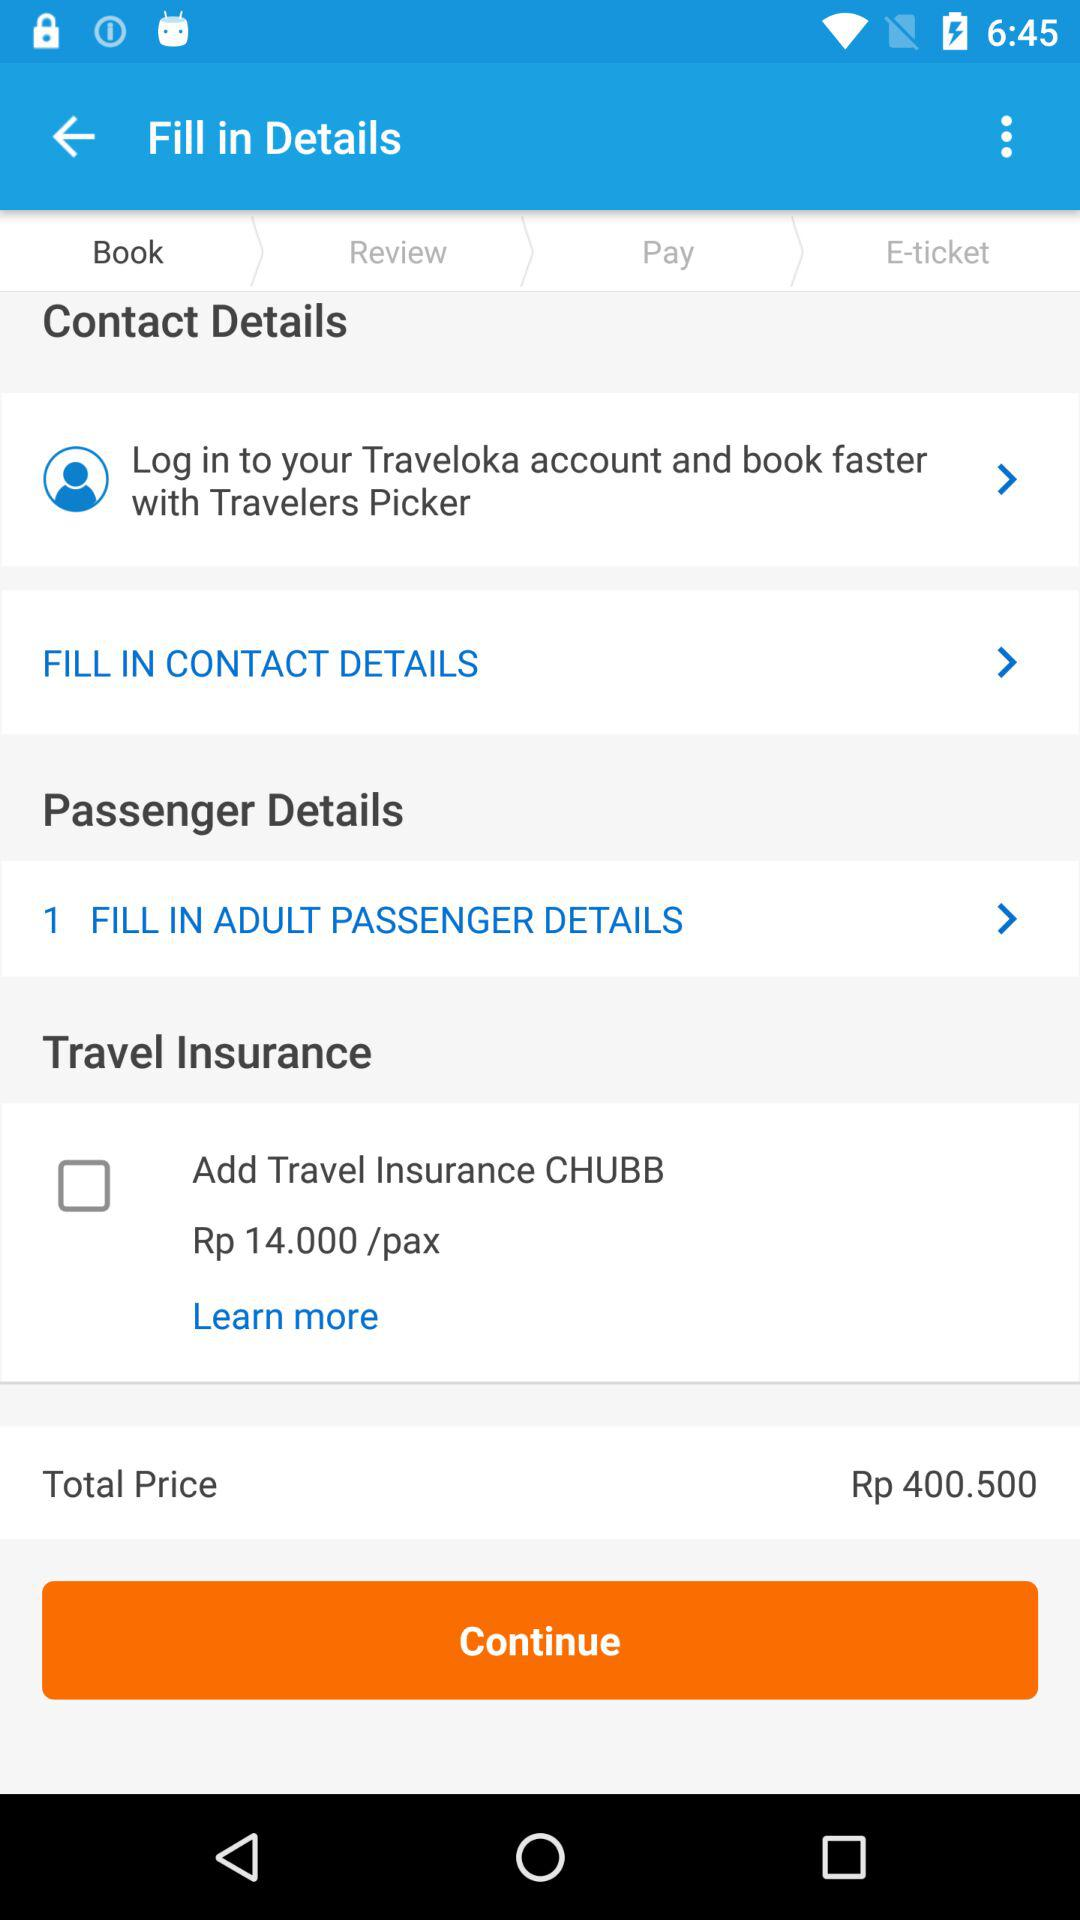How much is the total price of the ticket? The total price of the ticket displayed on the screen is Rp 400,500. Please ensure that this amount includes all necessary fees and taxes before completing your purchase. 